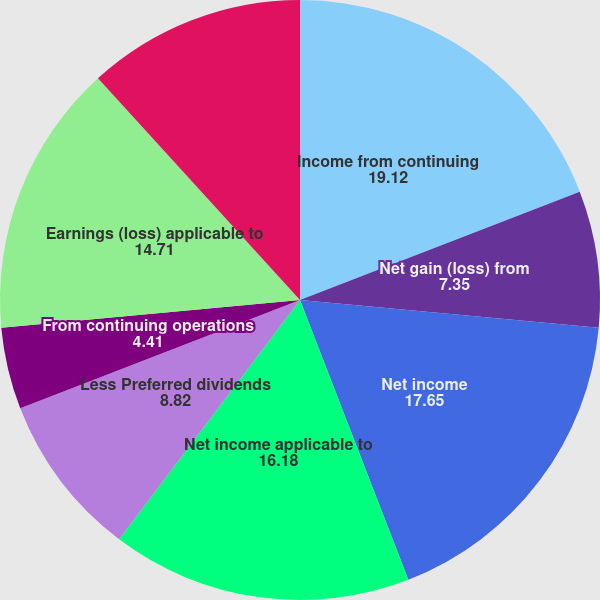<chart> <loc_0><loc_0><loc_500><loc_500><pie_chart><fcel>Income from continuing<fcel>Net gain (loss) from<fcel>Net income<fcel>Net income applicable to<fcel>Less Preferred dividends<fcel>From continuing operations<fcel>Earnings (loss) applicable to<fcel>Weighted average common shares<nl><fcel>19.12%<fcel>7.35%<fcel>17.65%<fcel>16.18%<fcel>8.82%<fcel>4.41%<fcel>14.71%<fcel>11.76%<nl></chart> 